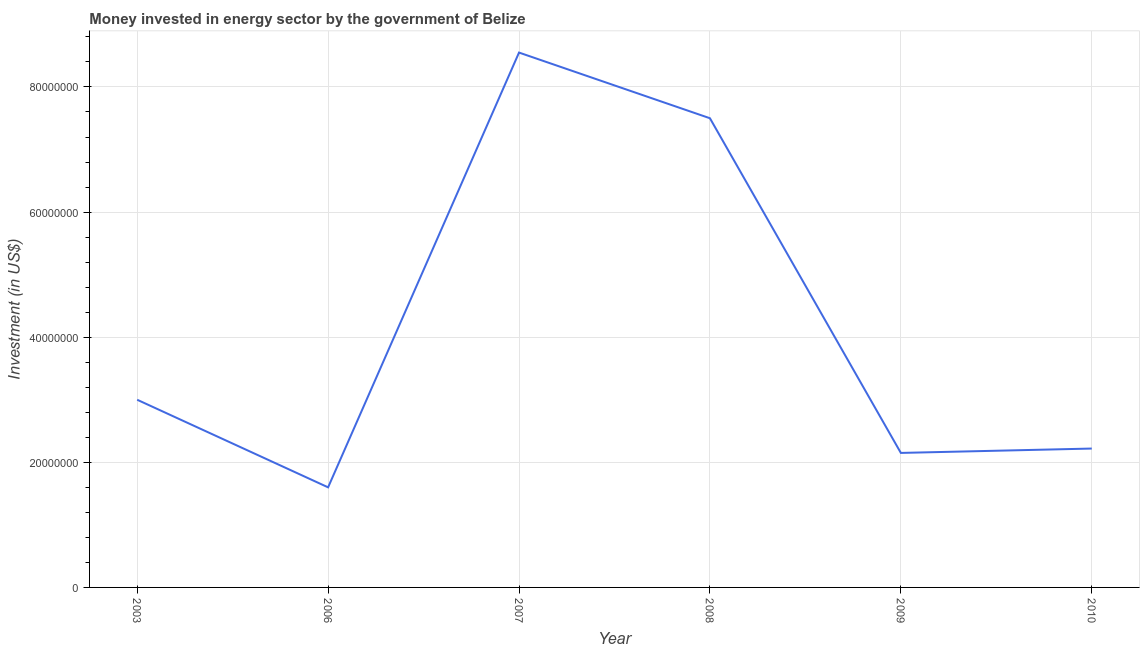What is the investment in energy in 2006?
Provide a short and direct response. 1.60e+07. Across all years, what is the maximum investment in energy?
Your answer should be compact. 8.55e+07. Across all years, what is the minimum investment in energy?
Make the answer very short. 1.60e+07. In which year was the investment in energy maximum?
Your answer should be compact. 2007. What is the sum of the investment in energy?
Give a very brief answer. 2.50e+08. What is the difference between the investment in energy in 2006 and 2010?
Make the answer very short. -6.20e+06. What is the average investment in energy per year?
Keep it short and to the point. 4.17e+07. What is the median investment in energy?
Offer a terse response. 2.61e+07. Do a majority of the years between 2009 and 2010 (inclusive) have investment in energy greater than 36000000 US$?
Your response must be concise. No. What is the ratio of the investment in energy in 2003 to that in 2007?
Your response must be concise. 0.35. Is the investment in energy in 2007 less than that in 2010?
Your response must be concise. No. Is the difference between the investment in energy in 2008 and 2009 greater than the difference between any two years?
Keep it short and to the point. No. What is the difference between the highest and the second highest investment in energy?
Keep it short and to the point. 1.05e+07. What is the difference between the highest and the lowest investment in energy?
Your response must be concise. 6.95e+07. Does the investment in energy monotonically increase over the years?
Your response must be concise. No. How many lines are there?
Make the answer very short. 1. What is the difference between two consecutive major ticks on the Y-axis?
Provide a short and direct response. 2.00e+07. Are the values on the major ticks of Y-axis written in scientific E-notation?
Offer a very short reply. No. Does the graph contain grids?
Provide a succinct answer. Yes. What is the title of the graph?
Keep it short and to the point. Money invested in energy sector by the government of Belize. What is the label or title of the Y-axis?
Provide a succinct answer. Investment (in US$). What is the Investment (in US$) of 2003?
Your response must be concise. 3.00e+07. What is the Investment (in US$) in 2006?
Provide a succinct answer. 1.60e+07. What is the Investment (in US$) in 2007?
Give a very brief answer. 8.55e+07. What is the Investment (in US$) in 2008?
Provide a short and direct response. 7.50e+07. What is the Investment (in US$) in 2009?
Give a very brief answer. 2.15e+07. What is the Investment (in US$) in 2010?
Your answer should be compact. 2.22e+07. What is the difference between the Investment (in US$) in 2003 and 2006?
Your answer should be compact. 1.40e+07. What is the difference between the Investment (in US$) in 2003 and 2007?
Give a very brief answer. -5.55e+07. What is the difference between the Investment (in US$) in 2003 and 2008?
Provide a succinct answer. -4.50e+07. What is the difference between the Investment (in US$) in 2003 and 2009?
Your response must be concise. 8.50e+06. What is the difference between the Investment (in US$) in 2003 and 2010?
Keep it short and to the point. 7.80e+06. What is the difference between the Investment (in US$) in 2006 and 2007?
Provide a succinct answer. -6.95e+07. What is the difference between the Investment (in US$) in 2006 and 2008?
Your response must be concise. -5.90e+07. What is the difference between the Investment (in US$) in 2006 and 2009?
Offer a very short reply. -5.50e+06. What is the difference between the Investment (in US$) in 2006 and 2010?
Offer a terse response. -6.20e+06. What is the difference between the Investment (in US$) in 2007 and 2008?
Your response must be concise. 1.05e+07. What is the difference between the Investment (in US$) in 2007 and 2009?
Provide a succinct answer. 6.40e+07. What is the difference between the Investment (in US$) in 2007 and 2010?
Offer a terse response. 6.33e+07. What is the difference between the Investment (in US$) in 2008 and 2009?
Offer a terse response. 5.35e+07. What is the difference between the Investment (in US$) in 2008 and 2010?
Make the answer very short. 5.28e+07. What is the difference between the Investment (in US$) in 2009 and 2010?
Your response must be concise. -7.00e+05. What is the ratio of the Investment (in US$) in 2003 to that in 2006?
Your answer should be very brief. 1.88. What is the ratio of the Investment (in US$) in 2003 to that in 2007?
Ensure brevity in your answer.  0.35. What is the ratio of the Investment (in US$) in 2003 to that in 2008?
Your answer should be very brief. 0.4. What is the ratio of the Investment (in US$) in 2003 to that in 2009?
Your response must be concise. 1.4. What is the ratio of the Investment (in US$) in 2003 to that in 2010?
Offer a terse response. 1.35. What is the ratio of the Investment (in US$) in 2006 to that in 2007?
Offer a very short reply. 0.19. What is the ratio of the Investment (in US$) in 2006 to that in 2008?
Offer a very short reply. 0.21. What is the ratio of the Investment (in US$) in 2006 to that in 2009?
Provide a succinct answer. 0.74. What is the ratio of the Investment (in US$) in 2006 to that in 2010?
Give a very brief answer. 0.72. What is the ratio of the Investment (in US$) in 2007 to that in 2008?
Ensure brevity in your answer.  1.14. What is the ratio of the Investment (in US$) in 2007 to that in 2009?
Give a very brief answer. 3.98. What is the ratio of the Investment (in US$) in 2007 to that in 2010?
Your answer should be very brief. 3.85. What is the ratio of the Investment (in US$) in 2008 to that in 2009?
Give a very brief answer. 3.49. What is the ratio of the Investment (in US$) in 2008 to that in 2010?
Make the answer very short. 3.38. What is the ratio of the Investment (in US$) in 2009 to that in 2010?
Ensure brevity in your answer.  0.97. 